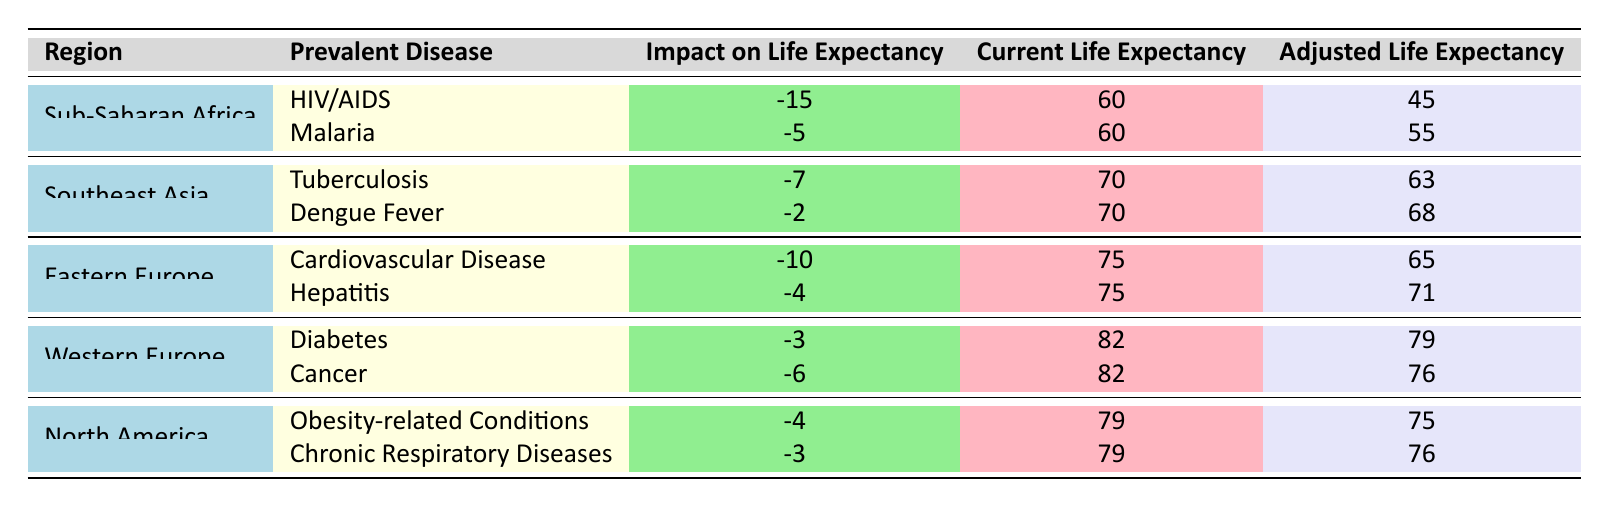What is the current life expectancy in Sub-Saharan Africa? The table shows that the current life expectancy for Sub-Saharan Africa is listed as 60 years.
Answer: 60 How much does HIV/AIDS reduce life expectancy in Eastern Europe? The table indicates that HIV/AIDS is not listed as a prevalent disease in Eastern Europe, hence it does not reduce life expectancy there.
Answer: 0 What is the adjusted life expectancy for patients in Western Europe with Diabetes? According to the table, the impact of Diabetes on life expectancy in Western Europe is -3 years, with a current life expectancy of 82 years. Therefore, the adjusted life expectancy is 82 - 3 = 79 years.
Answer: 79 Which region has the smallest impact on life expectancy from prevalent diseases? To find the smallest impact, we check the "Impact on Life Expectancy" column for all regions. The least impact is from Dengue Fever in Southeast Asia, which is -2 years.
Answer: Southeast Asia What is the average life expectancy of individuals living in North America after adjusting for prevalent diseases? The current life expectancy in North America is 79 years. The impact from the conditions listed (Obesity-related and Chronic Respiratory Diseases) is -4 and -3 years, respectively. Therefore, the adjusted life expectancy is calculated as follows: 79 - 4 - 3 = 72 years. To find the average adjusted life expectancy: there's only 1 adjusted value, so the average remains 72 years.
Answer: 72 Does Eastern Europe have a greater impact on life expectancy from Cardiovascular Disease than North America has from Obesity-related Conditions? From the table, the impact of Cardiovascular Disease in Eastern Europe is -10 years, while the impact of Obesity-related Conditions in North America is -4 years. Since -10 is less than -4, Eastern Europe does indeed have a greater negative impact.
Answer: Yes What is the total impact on life expectancy from prevalent diseases in Southeast Asia? In Southeast Asia, Tuberculosis decreases life expectancy by -7 years and Dengue Fever decreases it by -2 years. We sum these impacts: -7 + (-2) = -9 years total impact.
Answer: -9 Which region experiences the greatest loss in life expectancy from its prevalent diseases? By summing the impacts for each region: Sub-Saharan Africa has losses of -15 and -5 totaling -20, Southeast Asia has -7 and -2 totaling -9, Eastern Europe has -10 and -4 totaling -14, Western Europe has -3 and -6 totaling -9, and North America has -4 and -3 totaling -7. The region with the greatest total impact is Sub-Saharan Africa at -20 years.
Answer: Sub-Saharan Africa What is the difference in adjusted life expectancy between North America and Western Europe? The adjusted life expectancy for North America is 75 years (79 - 4) and for Western Europe is 76 years (82 - 6). The difference is calculated as: 76 - 75 = 1 year.
Answer: 1 